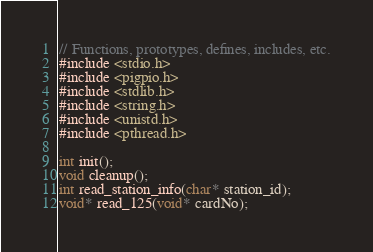Convert code to text. <code><loc_0><loc_0><loc_500><loc_500><_C_>// Functions, prototypes, defines, includes, etc.
#include <stdio.h>
#include <pigpio.h>
#include <stdlib.h>
#include <string.h>
#include <unistd.h>
#include <pthread.h>

int init();
void cleanup();
int read_station_info(char* station_id);
void* read_125(void* cardNo);

</code> 